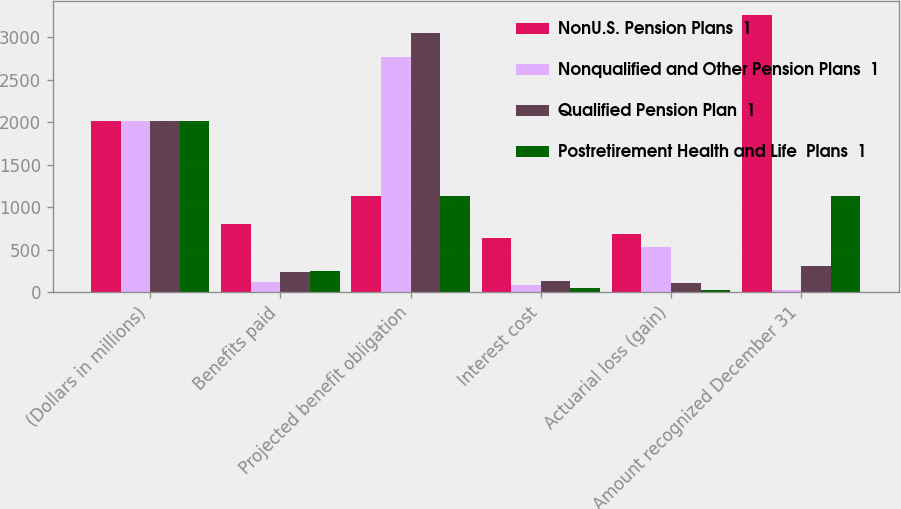<chart> <loc_0><loc_0><loc_500><loc_500><stacked_bar_chart><ecel><fcel>(Dollars in millions)<fcel>Benefits paid<fcel>Projected benefit obligation<fcel>Interest cost<fcel>Actuarial loss (gain)<fcel>Amount recognized December 31<nl><fcel>NonU.S. Pension Plans  1<fcel>2016<fcel>798<fcel>1125<fcel>634<fcel>685<fcel>3257<nl><fcel>Nonqualified and Other Pension Plans  1<fcel>2016<fcel>118<fcel>2763<fcel>86<fcel>535<fcel>26<nl><fcel>Qualified Pension Plan  1<fcel>2016<fcel>233<fcel>3047<fcel>127<fcel>106<fcel>303<nl><fcel>Postretirement Health and Life  Plans  1<fcel>2016<fcel>242<fcel>1125<fcel>47<fcel>25<fcel>1125<nl></chart> 